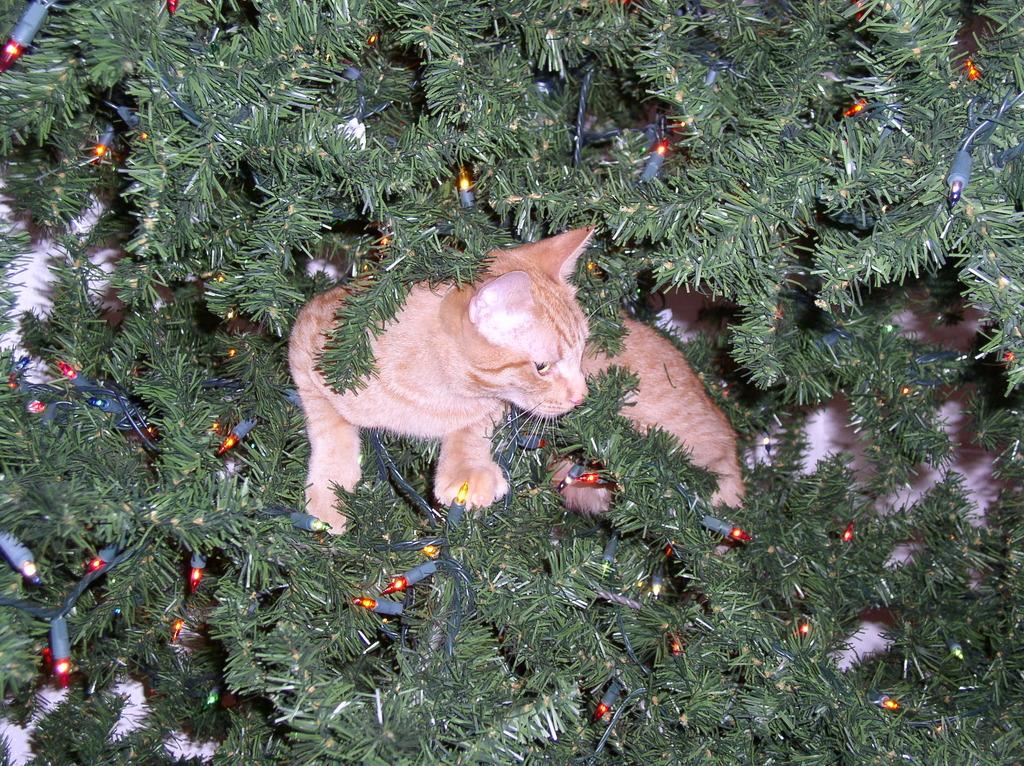What animal is present in the image? There is a cat in the image. Where is the cat located? The cat is on a tree. What additional objects can be seen near the cat? There are decorative lights beside the cat. How many owls are sitting on the cat's head in the image? There are no owls present in the image, and the cat's head is not mentioned as a location for any objects. 